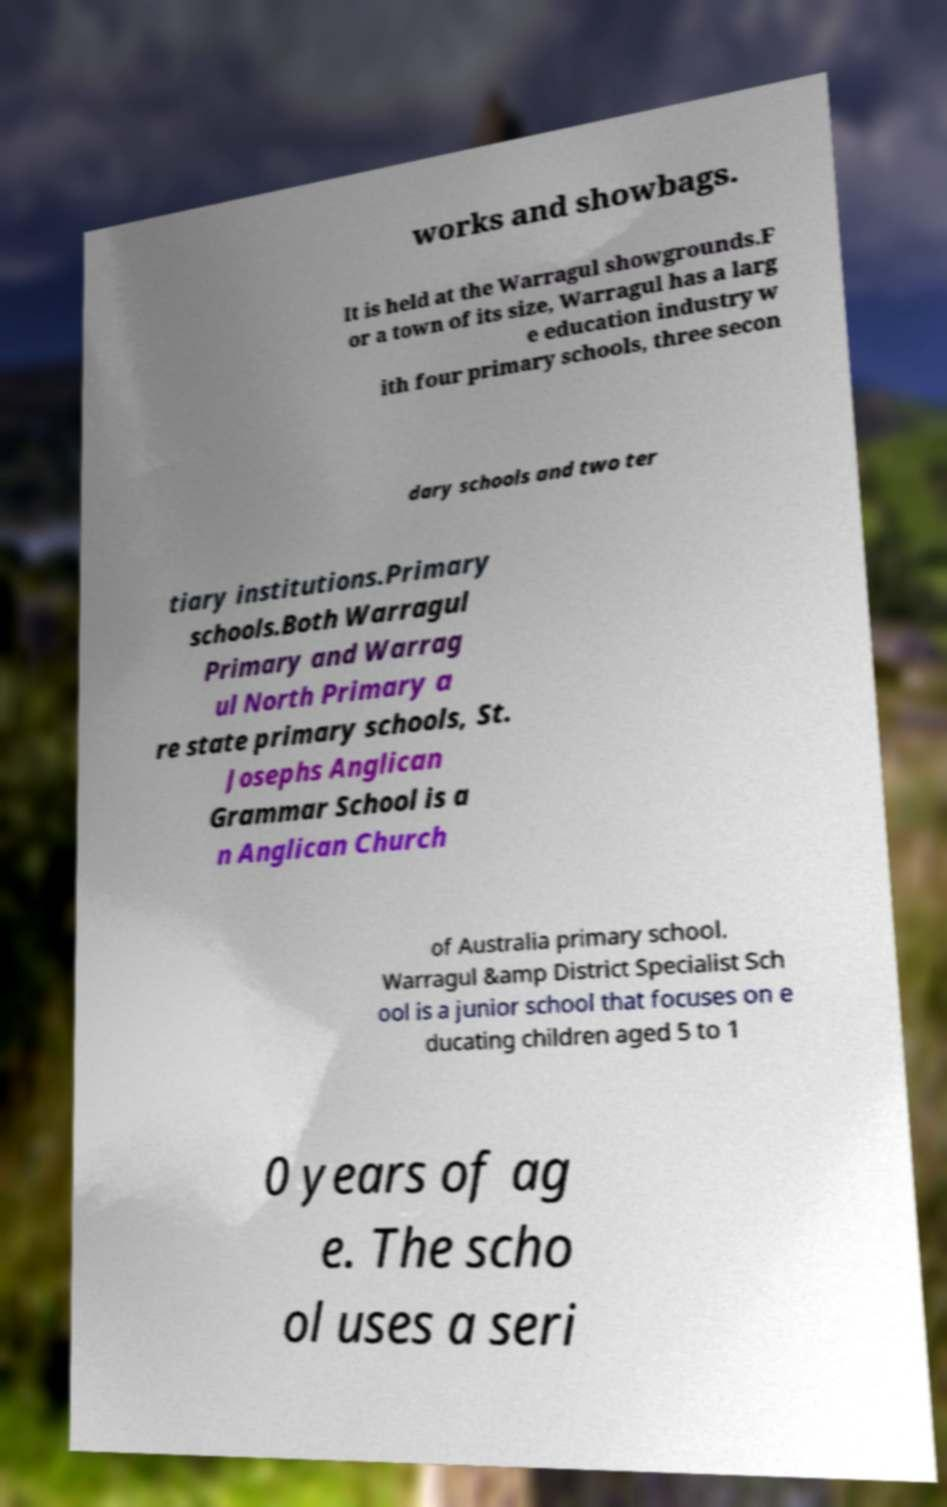Can you accurately transcribe the text from the provided image for me? works and showbags. It is held at the Warragul showgrounds.F or a town of its size, Warragul has a larg e education industry w ith four primary schools, three secon dary schools and two ter tiary institutions.Primary schools.Both Warragul Primary and Warrag ul North Primary a re state primary schools, St. Josephs Anglican Grammar School is a n Anglican Church of Australia primary school. Warragul &amp District Specialist Sch ool is a junior school that focuses on e ducating children aged 5 to 1 0 years of ag e. The scho ol uses a seri 